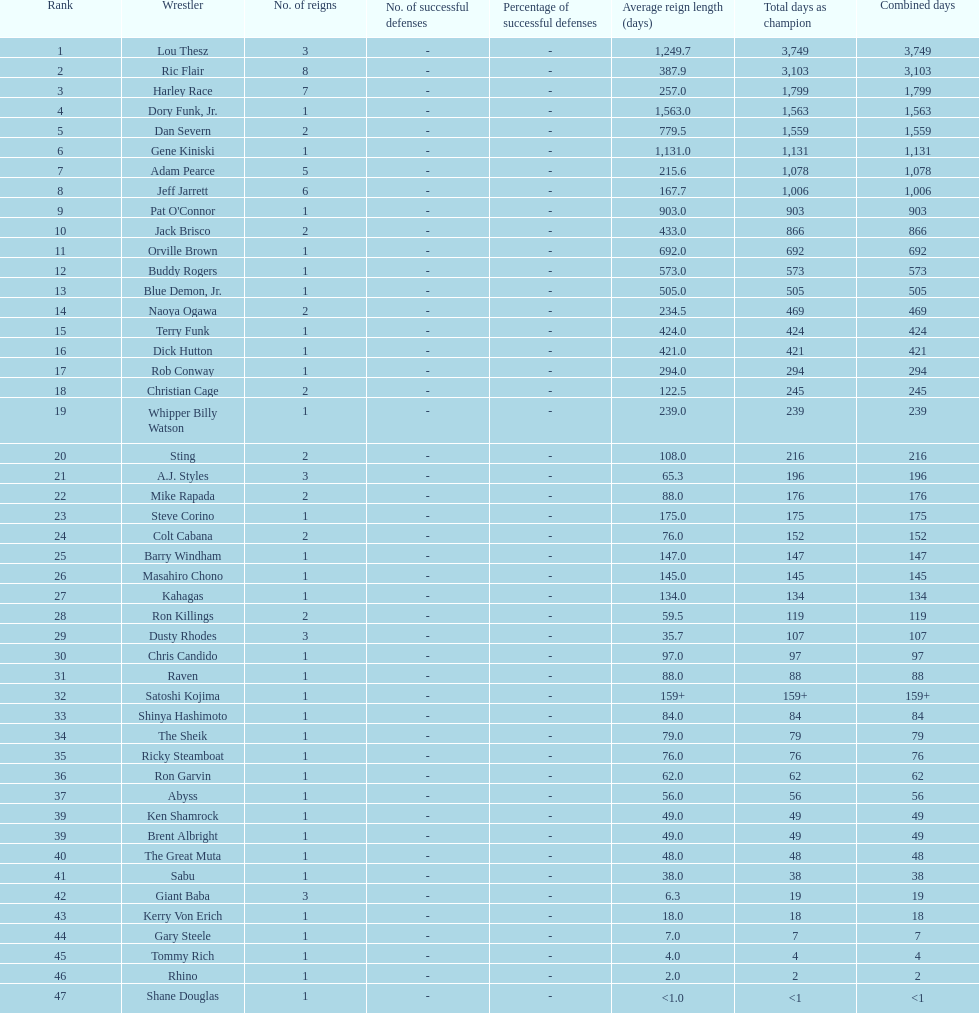Who has spent more time as nwa world heavyyweight champion, gene kiniski or ric flair? Ric Flair. 